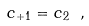Convert formula to latex. <formula><loc_0><loc_0><loc_500><loc_500>c _ { + 1 } = c _ { 2 } \ ,</formula> 